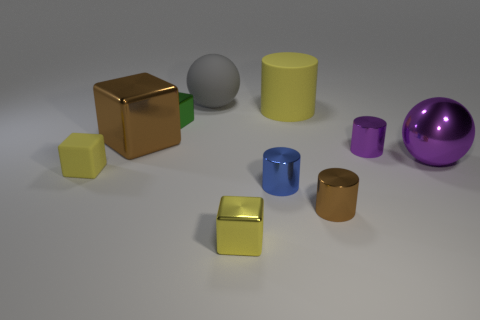The yellow object that is the same material as the big cylinder is what shape? cube 